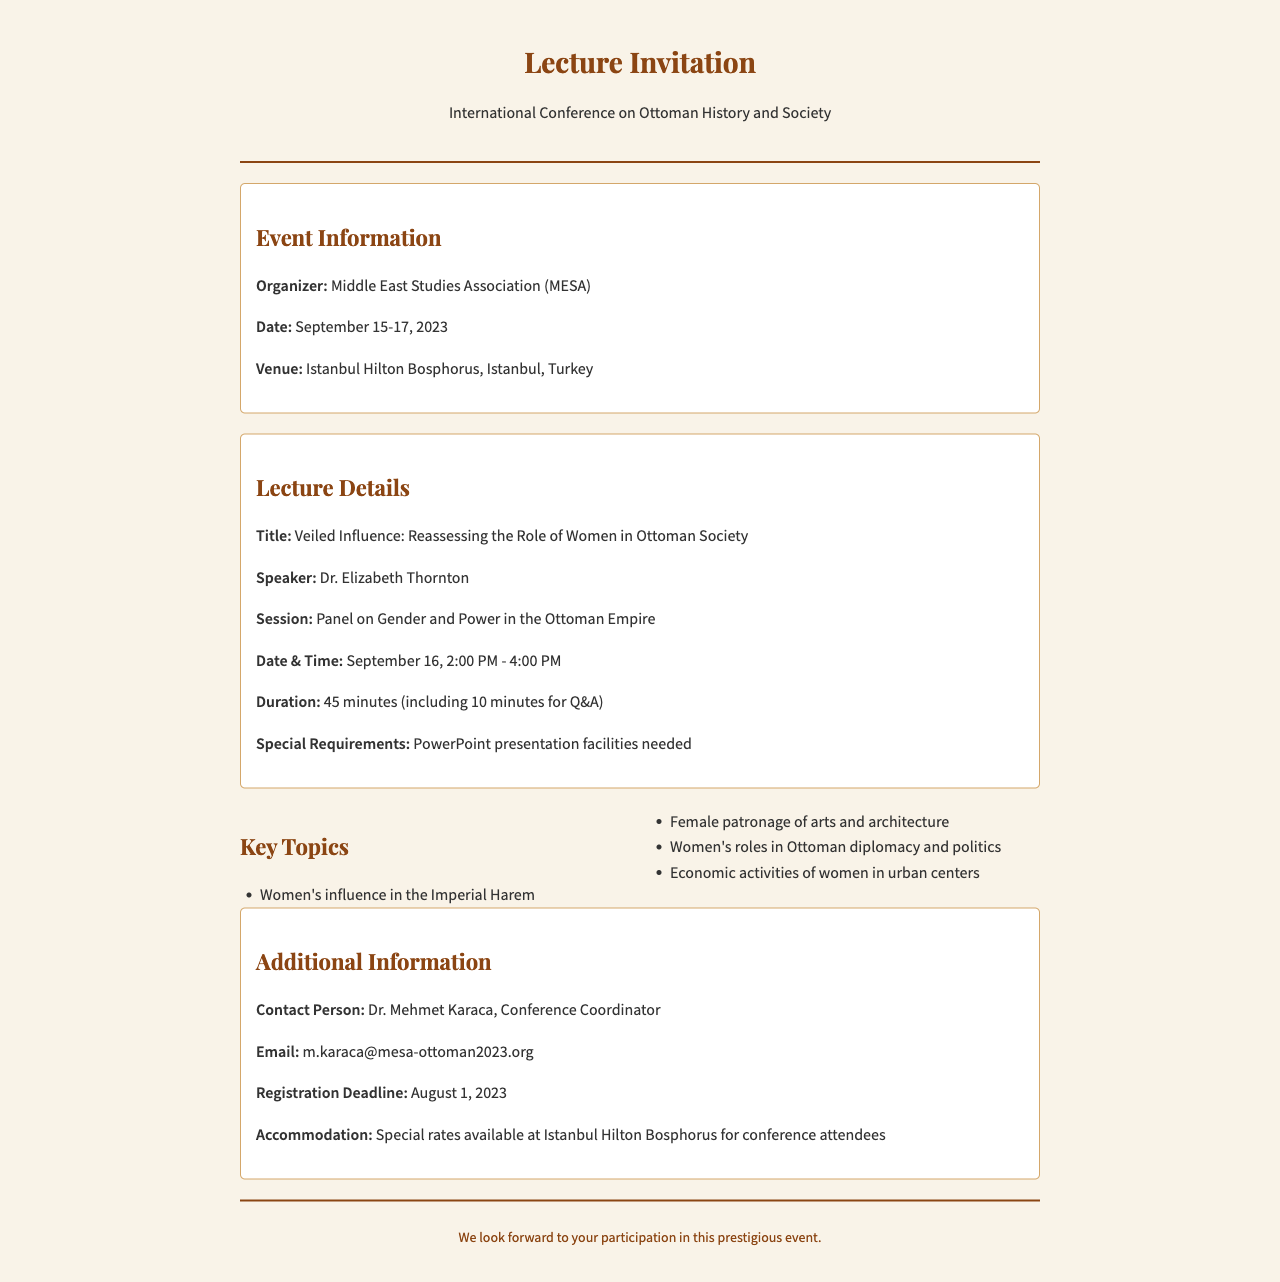What is the organizer of the conference? The document states that the event is organized by the Middle East Studies Association (MESA).
Answer: Middle East Studies Association (MESA) What are the dates of the conference? The conference is scheduled from September 15 to September 17, 2023.
Answer: September 15-17, 2023 What is the title of the lecture? The document mentions the title as "Veiled Influence: Reassessing the Role of Women in Ottoman Society."
Answer: Veiled Influence: Reassessing the Role of Women in Ottoman Society How long is the lecture duration? The document specifies that the lecture has a duration of 45 minutes, including 10 minutes for Q&A.
Answer: 45 minutes What key topic involves women's roles in diplomacy? The document lists "Women's roles in Ottoman diplomacy and politics" as one of the key topics.
Answer: Women's roles in Ottoman diplomacy and politics Who is the contact person for the conference? According to the document, the contact person is Dr. Mehmet Karaca, the conference coordinator.
Answer: Dr. Mehmet Karaca What special requirement is mentioned for the lecture? The document indicates that PowerPoint presentation facilities are needed for the lecture.
Answer: PowerPoint presentation facilities needed When is the registration deadline? The document specifies that the registration deadline is August 1, 2023.
Answer: August 1, 2023 